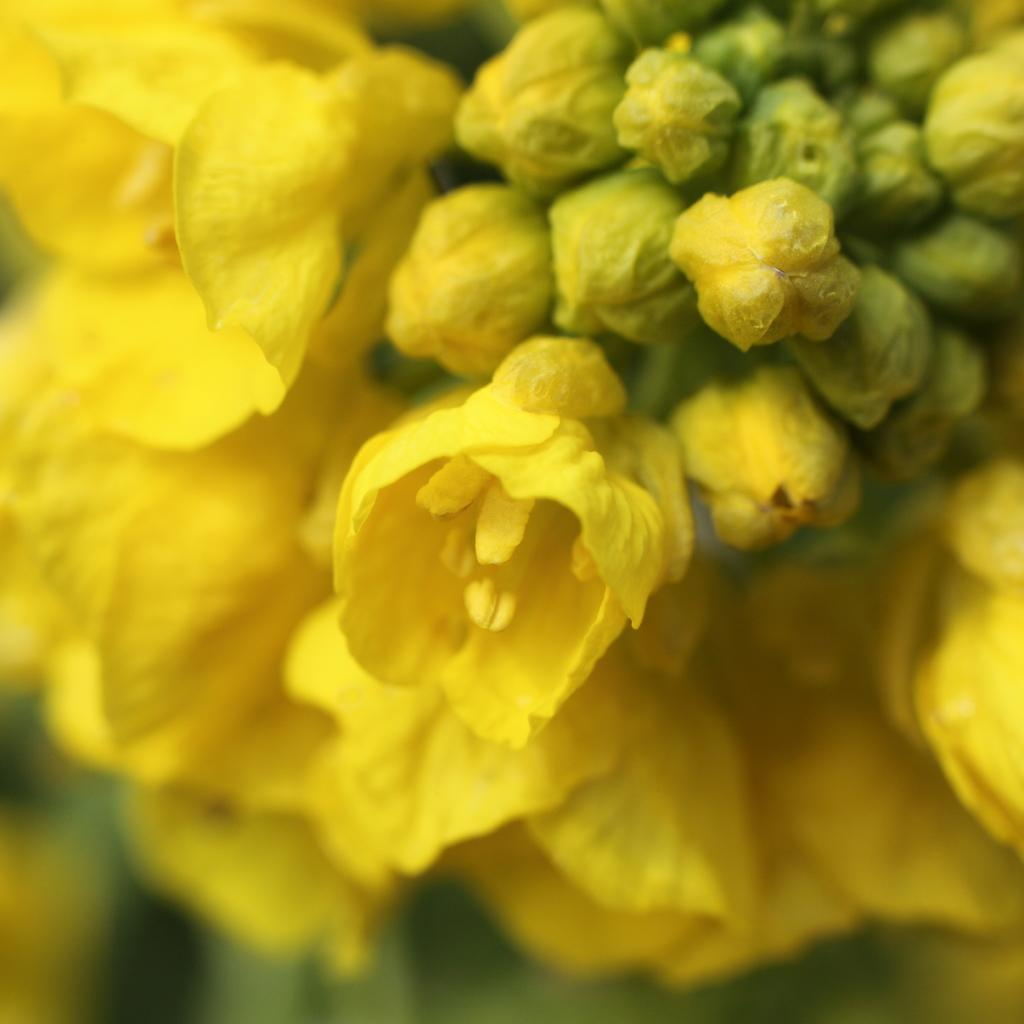What type of plants are in the image? There are flowers in the image. Can you describe the stage of growth for some of the plants? There are buds in the image. What color are the flowers and buds in the image? The flowers and buds are yellow in color. How many passengers are visible in the image? There are no passengers present in the image; it features flowers and buds. What type of act is being performed in the image? There is no act being performed in the image; it features flowers and buds. 